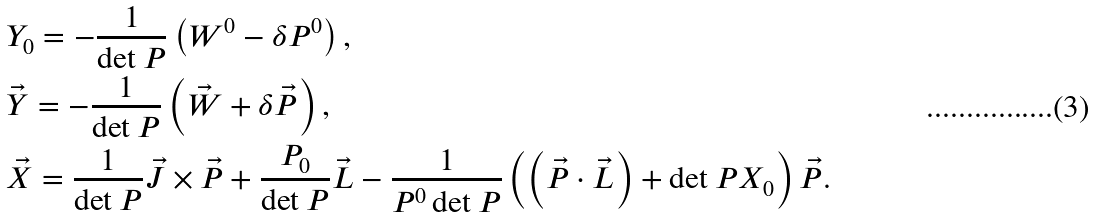<formula> <loc_0><loc_0><loc_500><loc_500>& Y _ { 0 } = - \frac { 1 } { \det P } \left ( W ^ { 0 } - \delta P ^ { 0 } \right ) , \\ & \vec { Y } = - \frac { 1 } { \det P } \left ( \vec { W } + \delta \vec { P } \right ) , \\ & \vec { X } = \frac { 1 } { \det P } \vec { J } \times \vec { P } + \frac { P _ { 0 } } { \det P } \vec { L } - \frac { 1 } { P ^ { 0 } \det P } \left ( \left ( \vec { P } \cdot \vec { L } \right ) + \det P X _ { 0 } \right ) \vec { P } .</formula> 